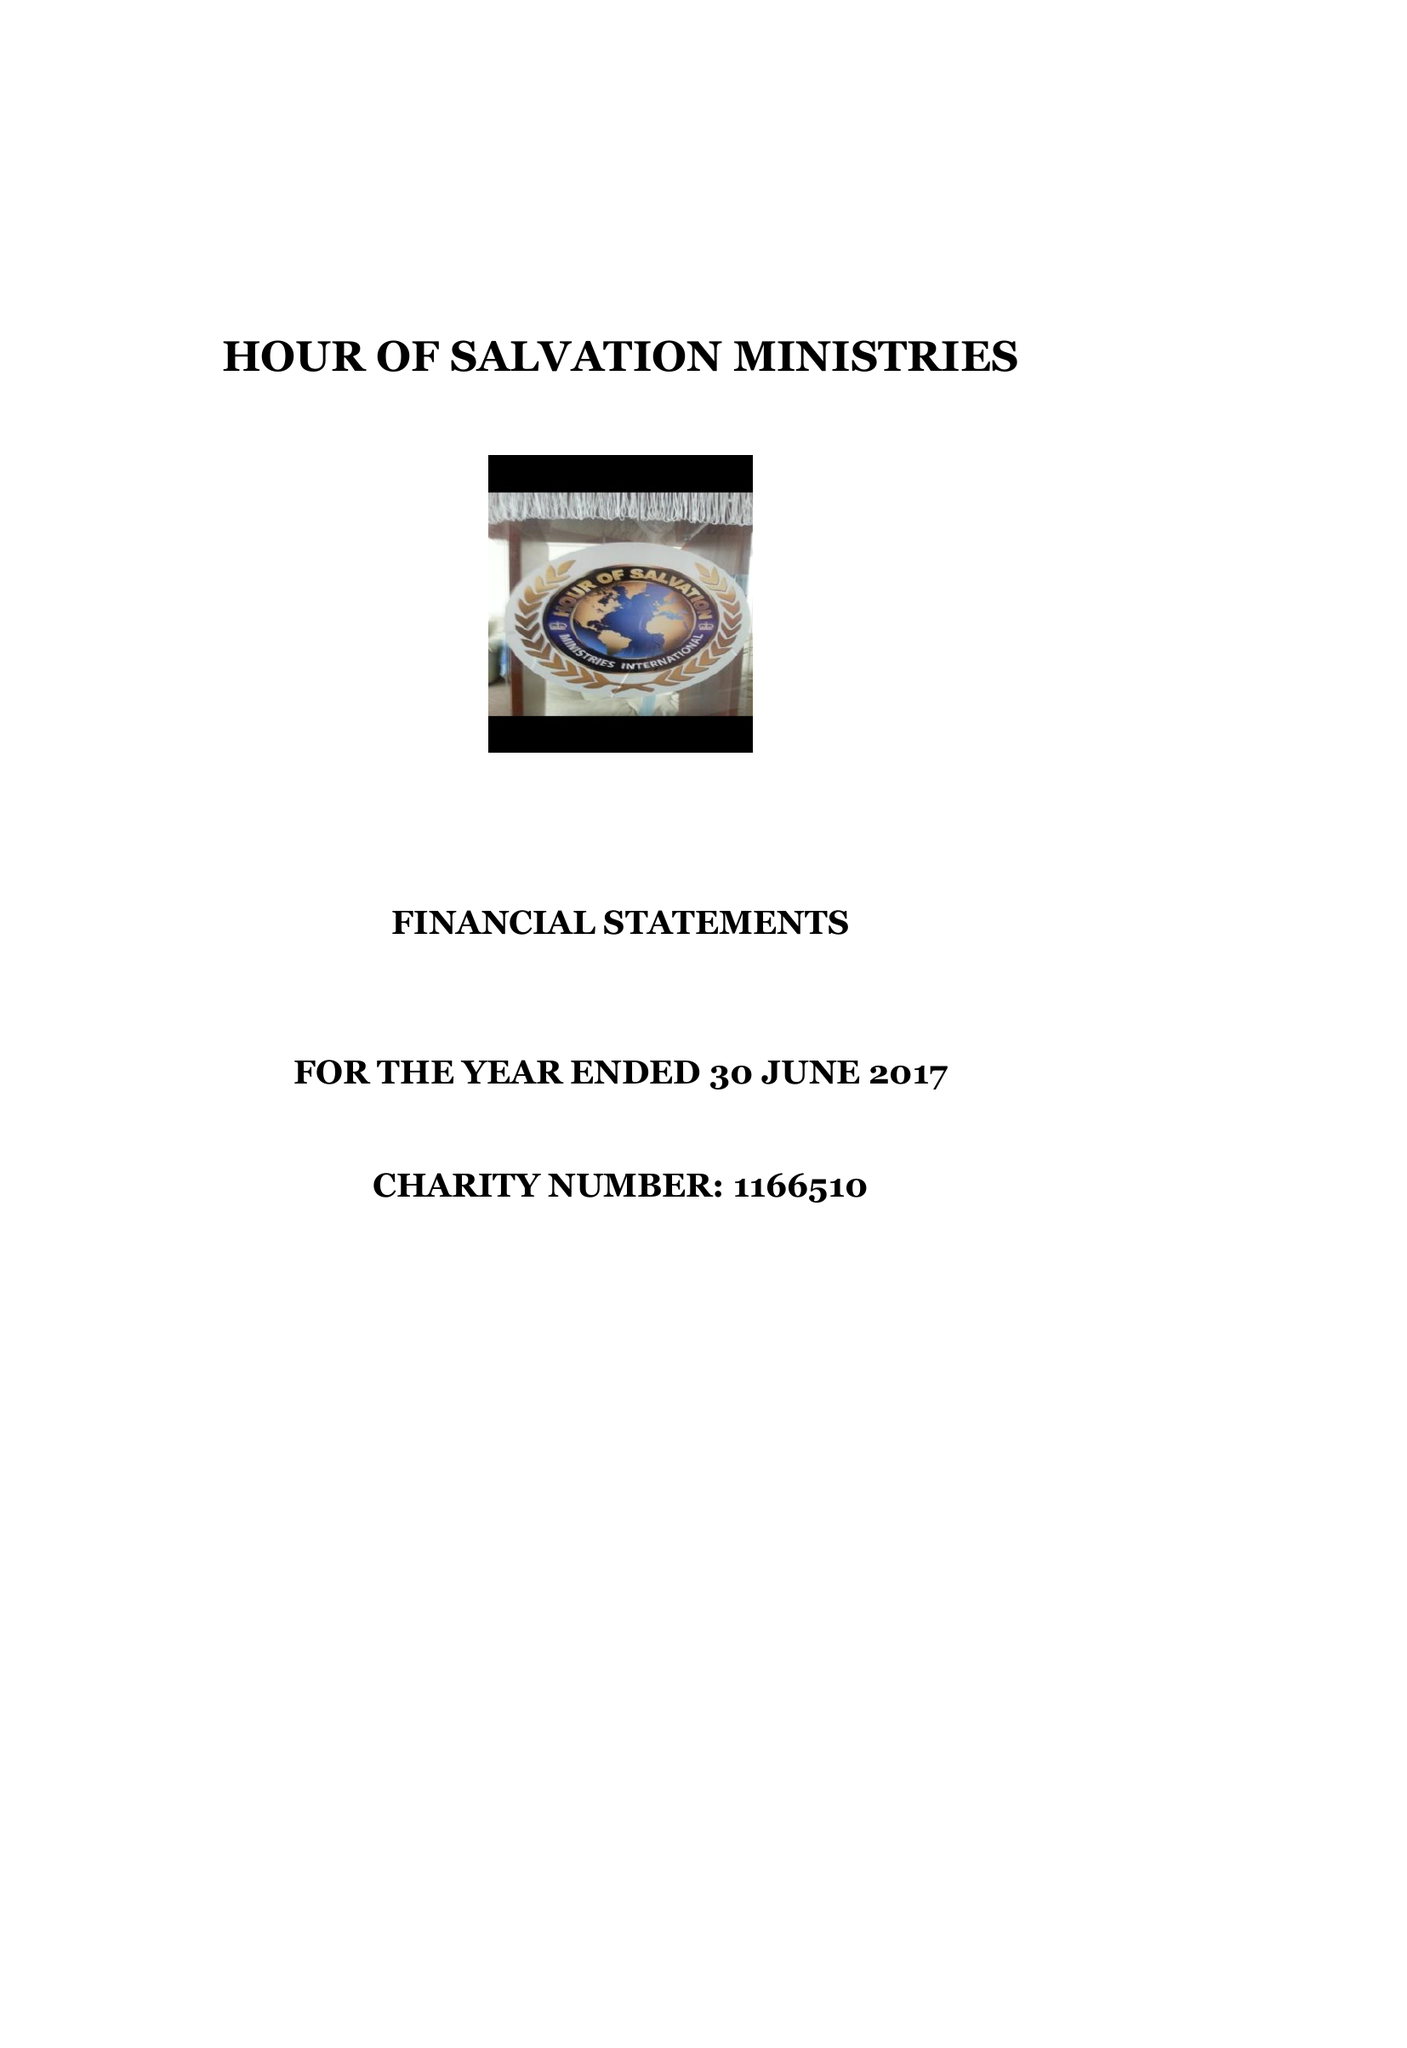What is the value for the address__street_line?
Answer the question using a single word or phrase. 12 FORRABURY AVENUE 